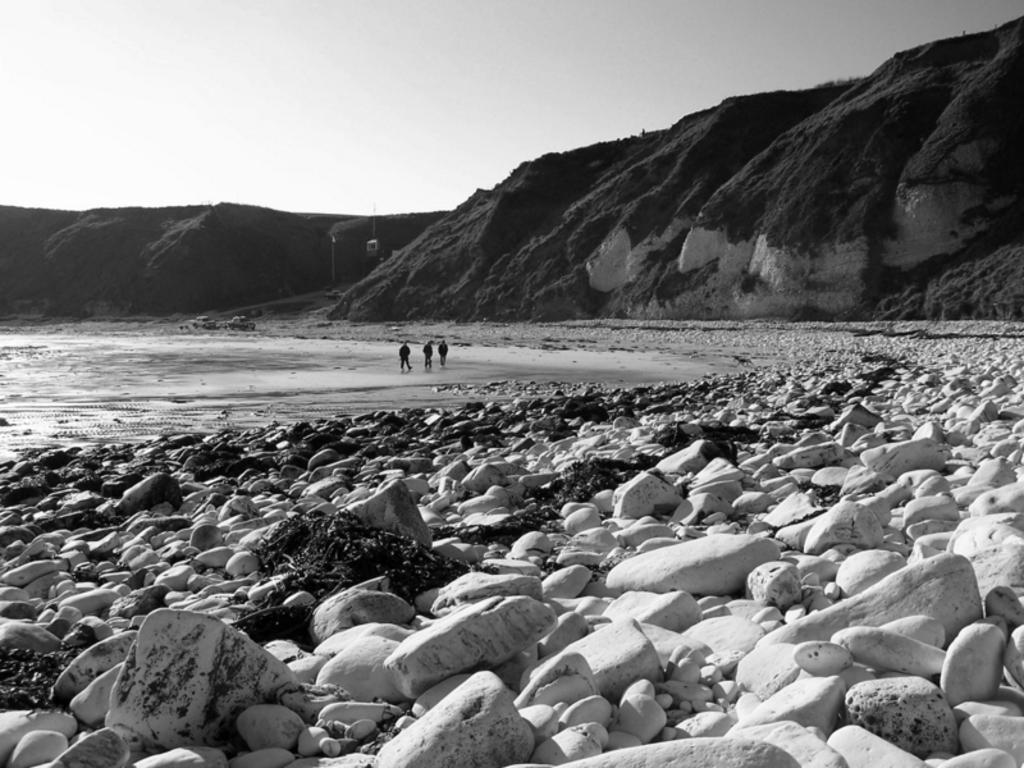Can you describe this image briefly? This is a black and white image. In this image we can see persons, stones, water, hills and sky. 